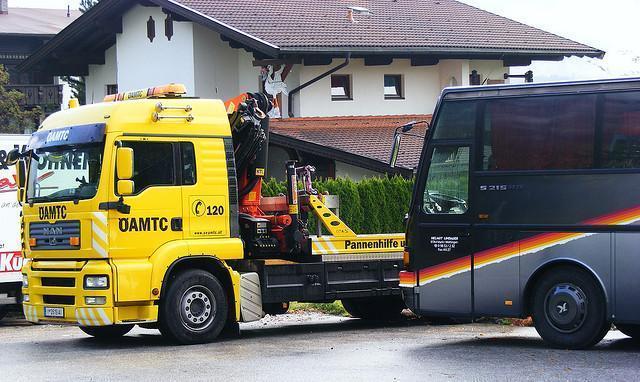Is this affirmation: "The truck is at the left side of the bus." correct?
Answer yes or no. Yes. 